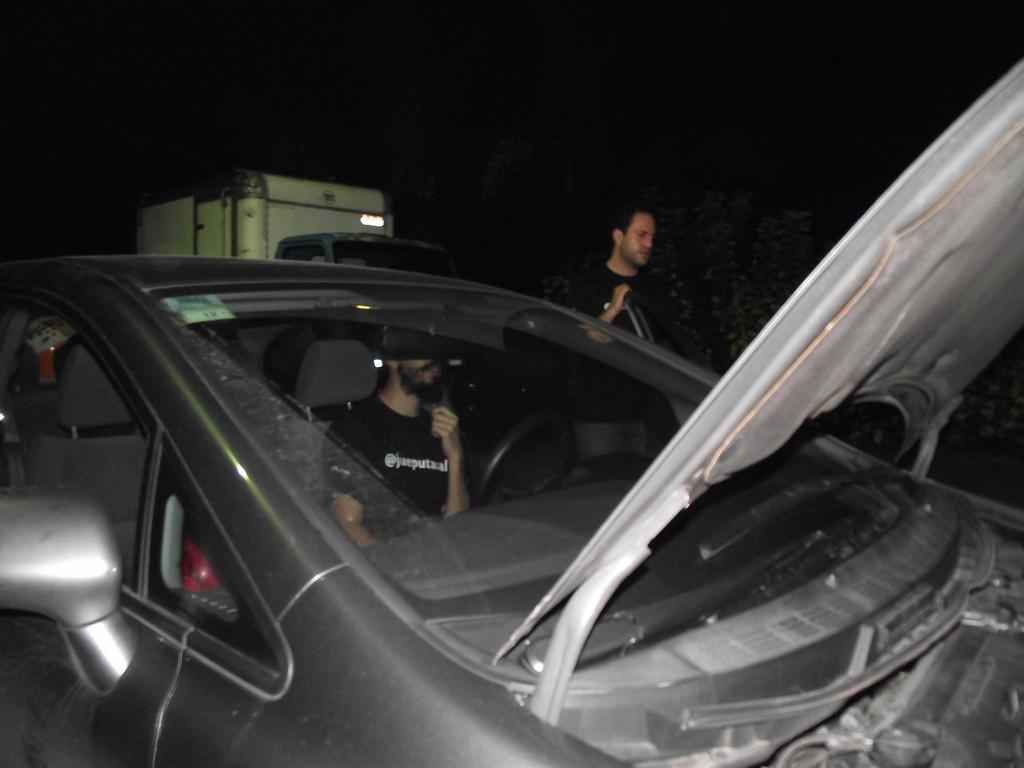Can you describe this image briefly? In this image I can see a car and two men, a man is sitting in a car and a man standing on the floor. 